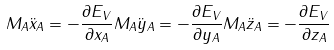Convert formula to latex. <formula><loc_0><loc_0><loc_500><loc_500>M _ { A } { \ddot { x } } _ { A } = - \frac { \partial E _ { V } } { \partial x _ { A } } M _ { A } { \ddot { y } } _ { A } = - \frac { \partial E _ { V } } { \partial y _ { A } } M _ { A } { \ddot { z } } _ { A } = - \frac { \partial E _ { V } } { \partial z _ { A } }</formula> 